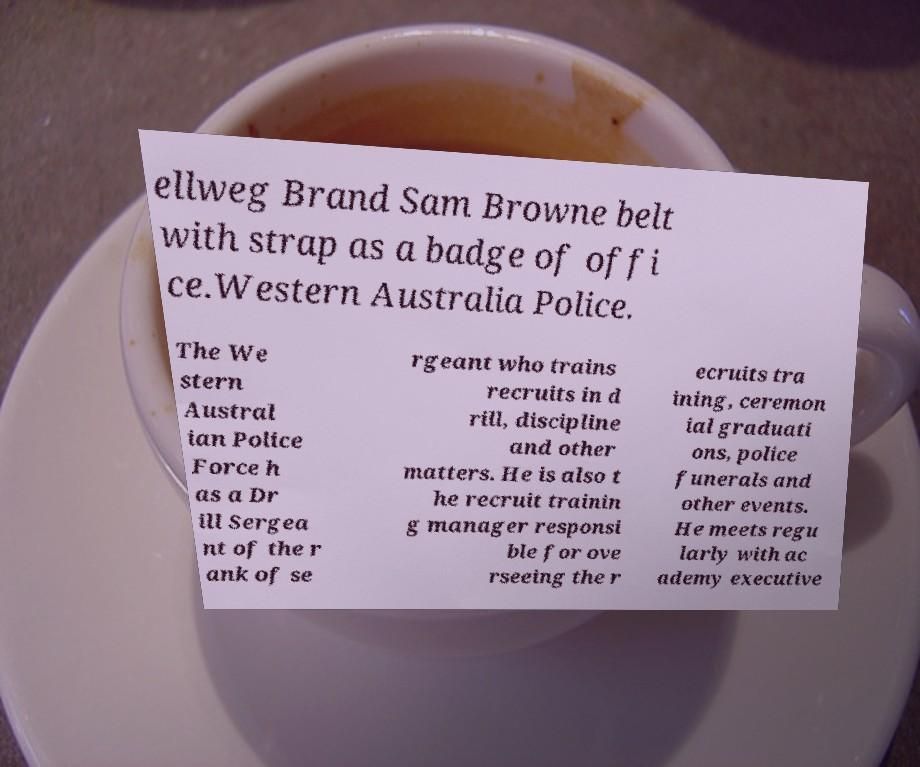There's text embedded in this image that I need extracted. Can you transcribe it verbatim? ellweg Brand Sam Browne belt with strap as a badge of offi ce.Western Australia Police. The We stern Austral ian Police Force h as a Dr ill Sergea nt of the r ank of se rgeant who trains recruits in d rill, discipline and other matters. He is also t he recruit trainin g manager responsi ble for ove rseeing the r ecruits tra ining, ceremon ial graduati ons, police funerals and other events. He meets regu larly with ac ademy executive 